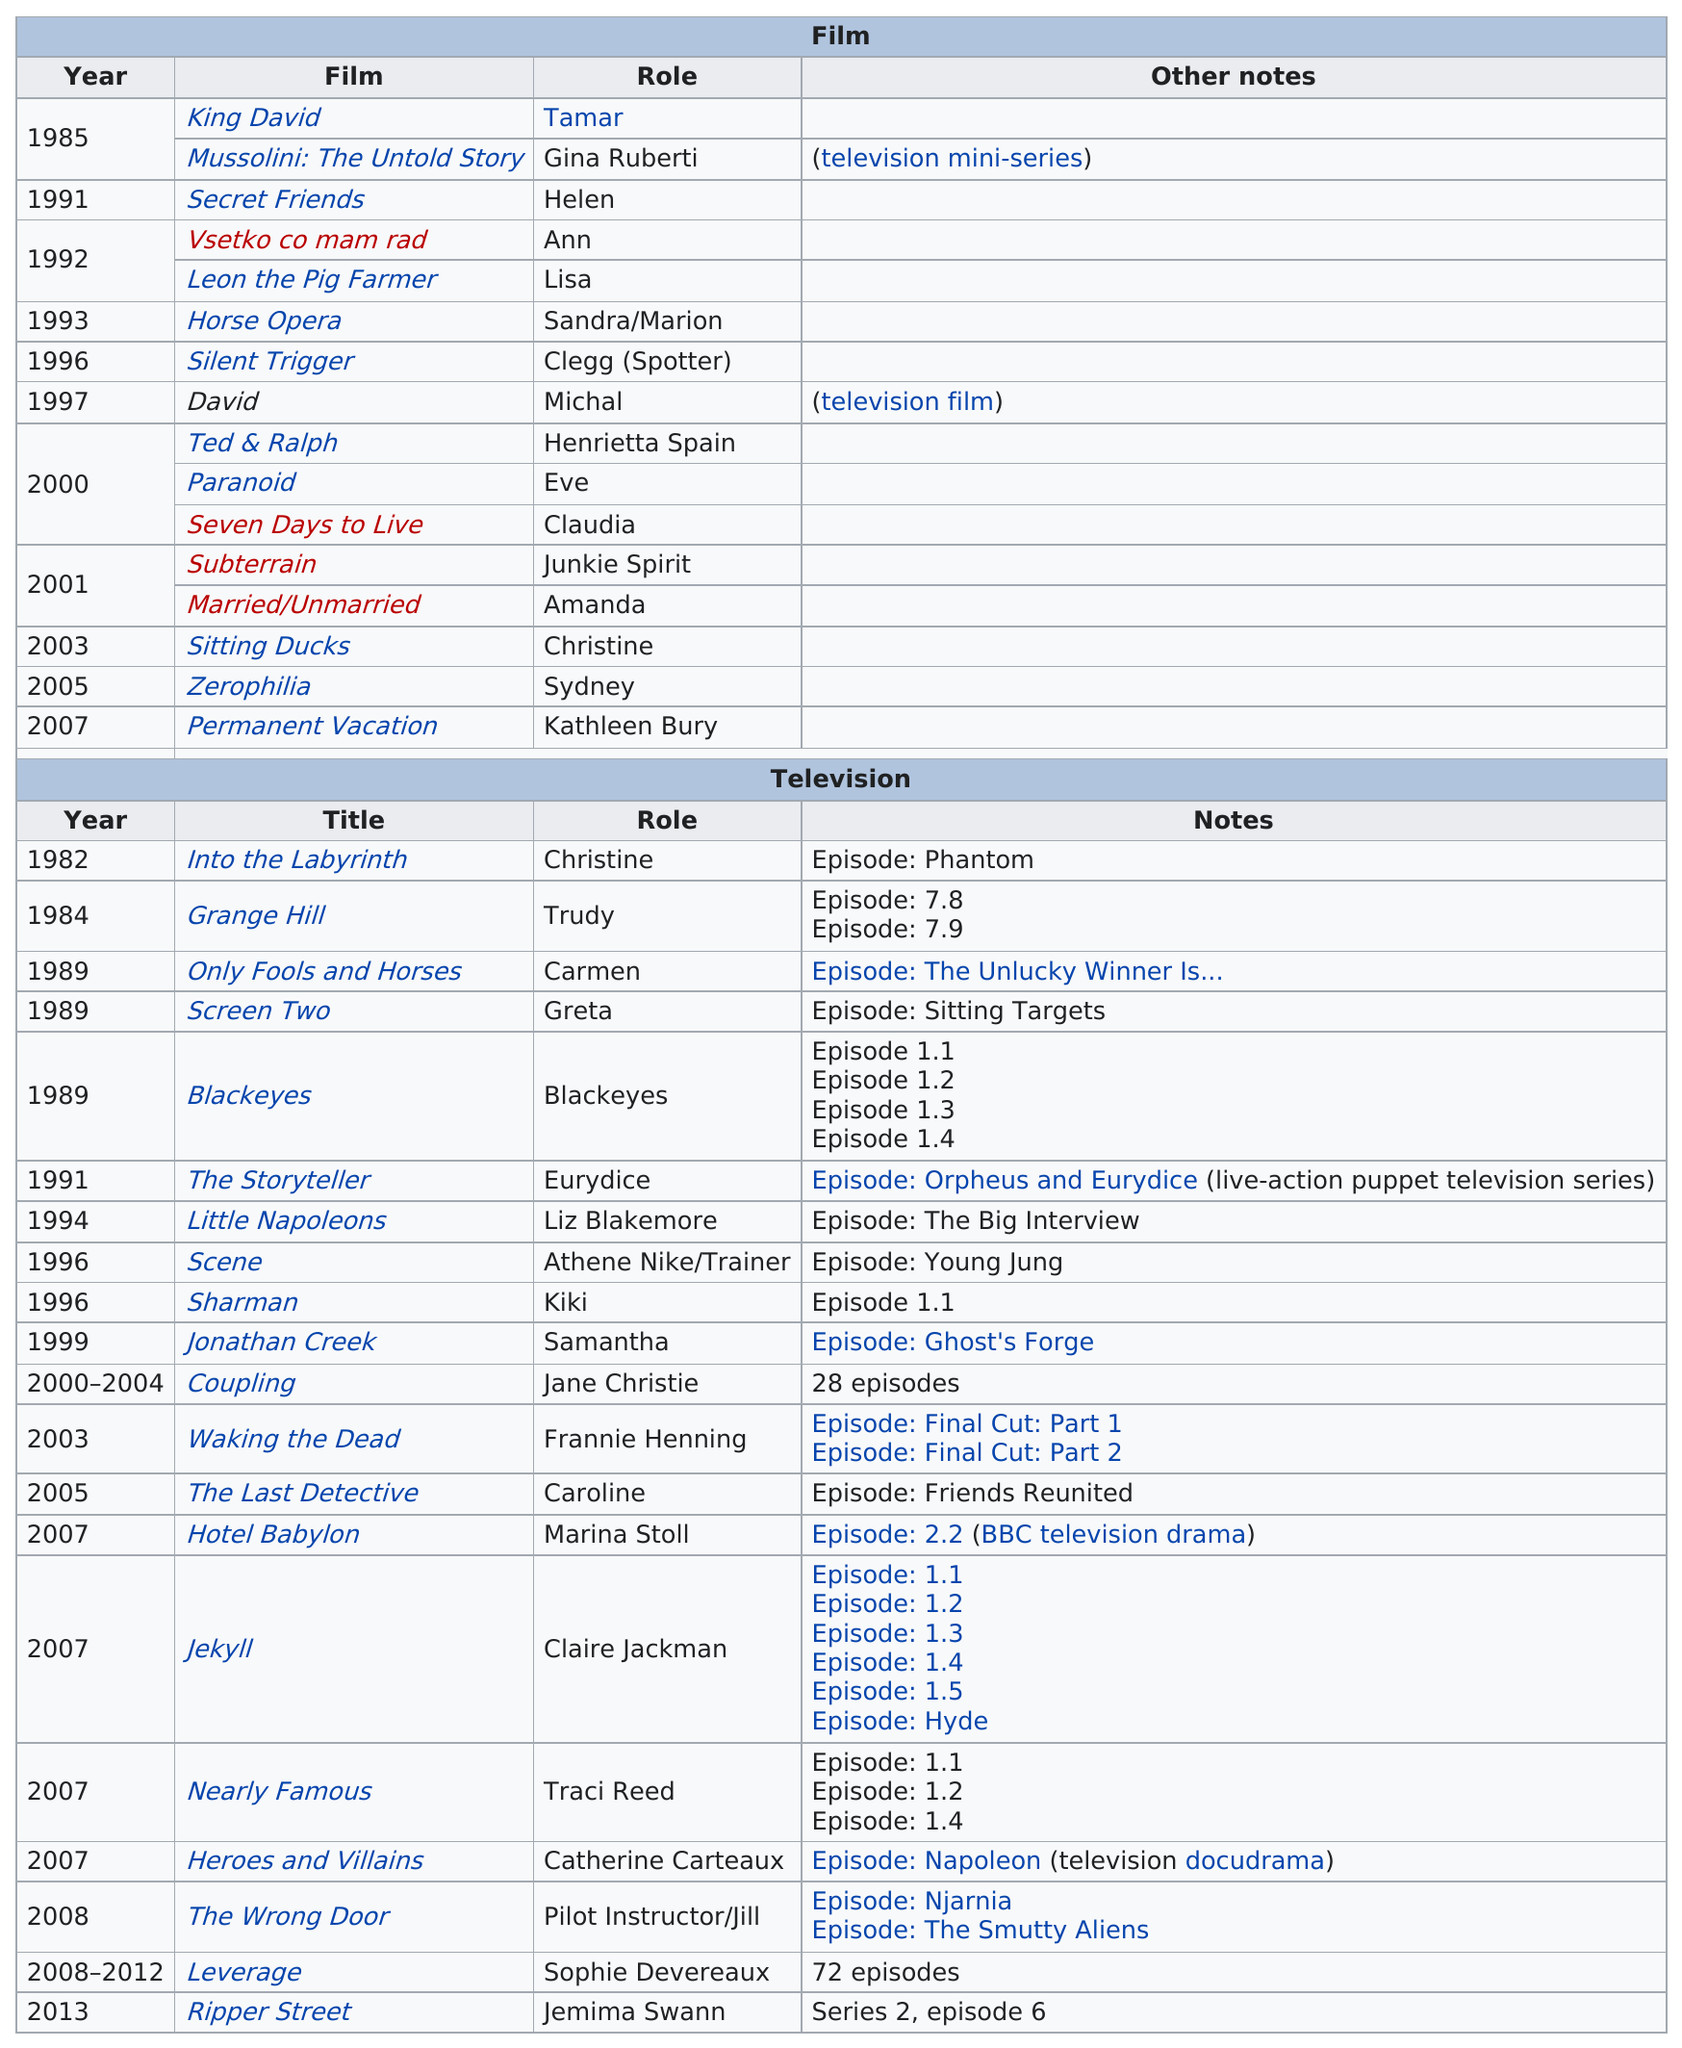Specify some key components in this picture. Tamar was the first character that the speaker played in her first movie. Gina Bellman played two roles in which her character was named Christine. In the year 2000, she acted in the most movies out of all the years in her filmography. 